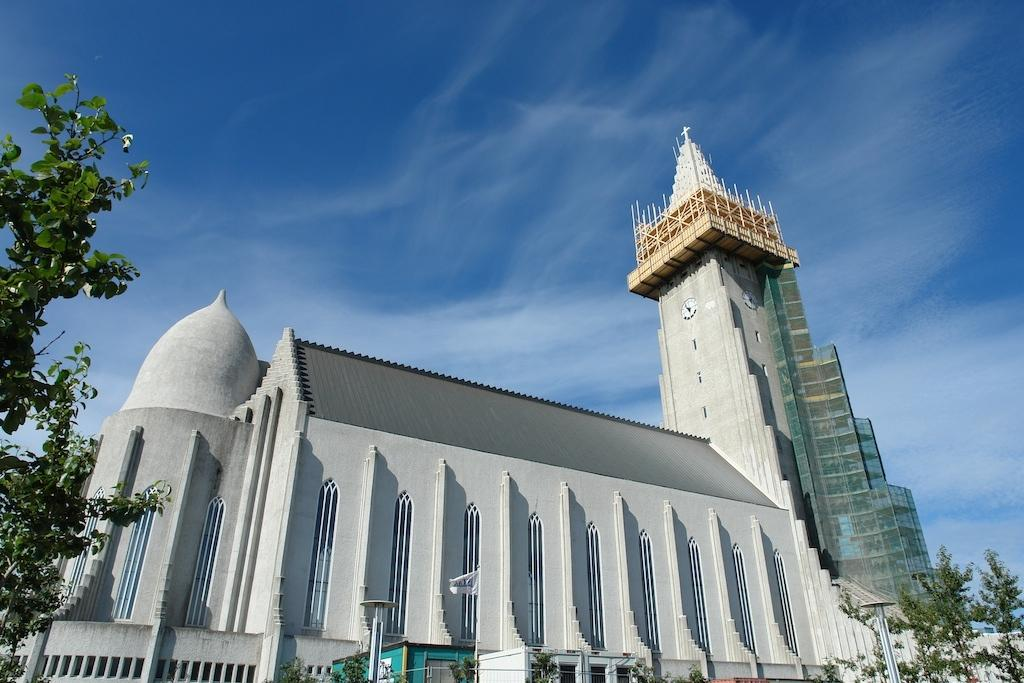What type of structure can be seen in the image? There is a building in the image. What natural elements are present in the image? There are trees in the image. What man-made objects can be seen in the image? There are poles in the image. What else is visible in the image besides the building, trees, and poles? There are other objects in the image. What can be seen in the background of the image? The sky is visible in the background of the image. Where is the tree located in the image? There is a tree on the left side of the image. What type of camera can be seen in the image? There is no camera present in the image. What type of street is visible in the image? There is no street visible in the image. 